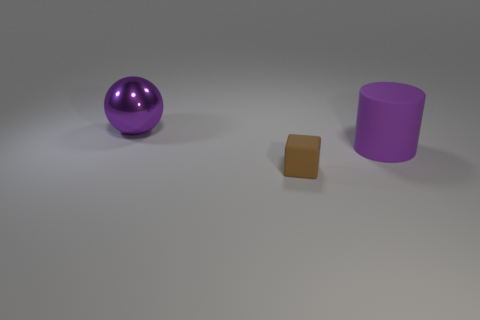What number of objects are either things right of the small brown cube or small things?
Offer a very short reply. 2. There is a purple object to the right of the large ball; how big is it?
Your response must be concise. Large. Are there fewer brown blocks than green metal cubes?
Provide a succinct answer. No. Do the big thing that is in front of the purple sphere and the big thing that is left of the brown cube have the same material?
Give a very brief answer. No. What is the shape of the big object left of the tiny brown object that is in front of the object to the left of the brown cube?
Give a very brief answer. Sphere. What number of tiny brown objects have the same material as the big purple cylinder?
Keep it short and to the point. 1. There is a brown matte object to the left of the purple matte cylinder; what number of large purple matte cylinders are to the right of it?
Your answer should be compact. 1. Does the large object that is to the left of the small brown cube have the same color as the matte thing in front of the big purple matte thing?
Provide a short and direct response. No. The object that is both in front of the purple shiny thing and left of the rubber cylinder has what shape?
Offer a very short reply. Cube. Are there any big cyan shiny things that have the same shape as the brown matte object?
Keep it short and to the point. No. 